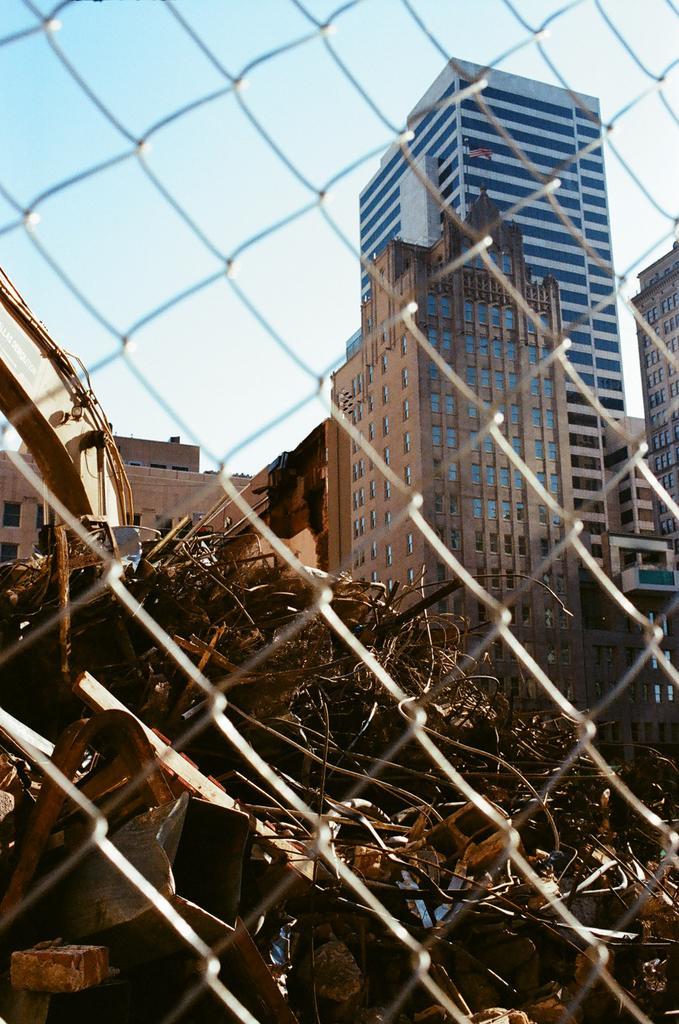Please provide a concise description of this image. In this image we can see a dried leaf on the ground. In the foreground of the image there is a net. In the background of the image there are buildings and sky. 